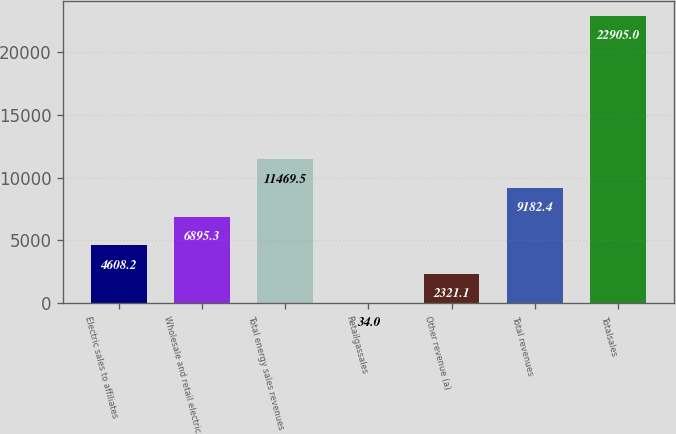<chart> <loc_0><loc_0><loc_500><loc_500><bar_chart><fcel>Electric sales to affiliates<fcel>Wholesale and retail electric<fcel>Total energy sales revenues<fcel>Retailgassales<fcel>Other revenue (a)<fcel>Total revenues<fcel>Totalsales<nl><fcel>4608.2<fcel>6895.3<fcel>11469.5<fcel>34<fcel>2321.1<fcel>9182.4<fcel>22905<nl></chart> 